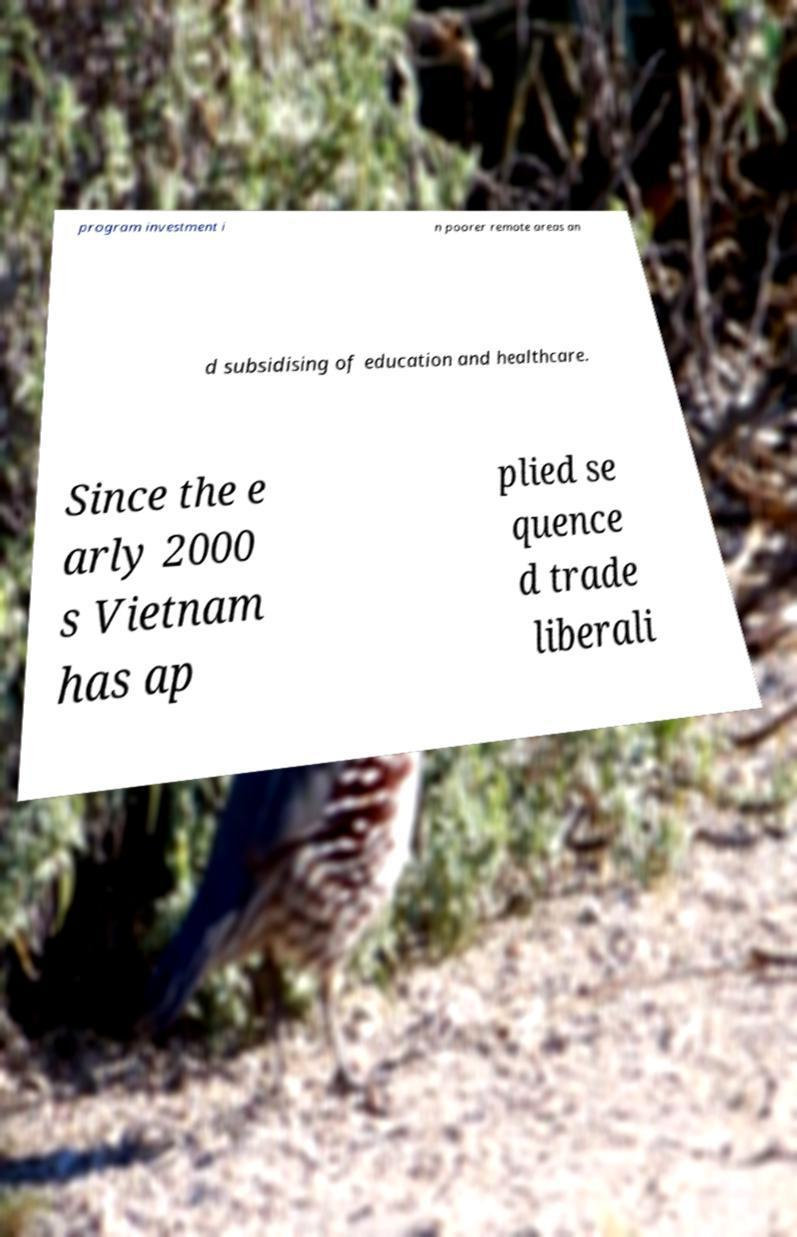Could you assist in decoding the text presented in this image and type it out clearly? program investment i n poorer remote areas an d subsidising of education and healthcare. Since the e arly 2000 s Vietnam has ap plied se quence d trade liberali 